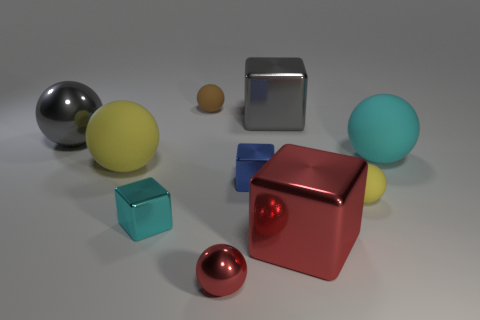Do the large gray cube that is behind the cyan metallic object and the cyan thing that is right of the large gray cube have the same material?
Give a very brief answer. No. The tiny sphere that is made of the same material as the tiny brown thing is what color?
Provide a short and direct response. Yellow. Is the number of large cubes in front of the big yellow rubber sphere greater than the number of blue metal blocks right of the large red object?
Your answer should be very brief. Yes. Are there any brown rubber balls?
Your answer should be very brief. Yes. There is a cube that is the same color as the small metal sphere; what is its material?
Offer a terse response. Metal. How many objects are gray matte spheres or red blocks?
Make the answer very short. 1. Is there a large shiny object that has the same color as the large shiny sphere?
Make the answer very short. Yes. There is a large rubber thing to the right of the big yellow matte thing; what number of tiny blue shiny blocks are behind it?
Make the answer very short. 0. Are there more big gray metal balls than big cyan rubber cylinders?
Provide a succinct answer. Yes. Do the big gray ball and the big red thing have the same material?
Offer a very short reply. Yes. 